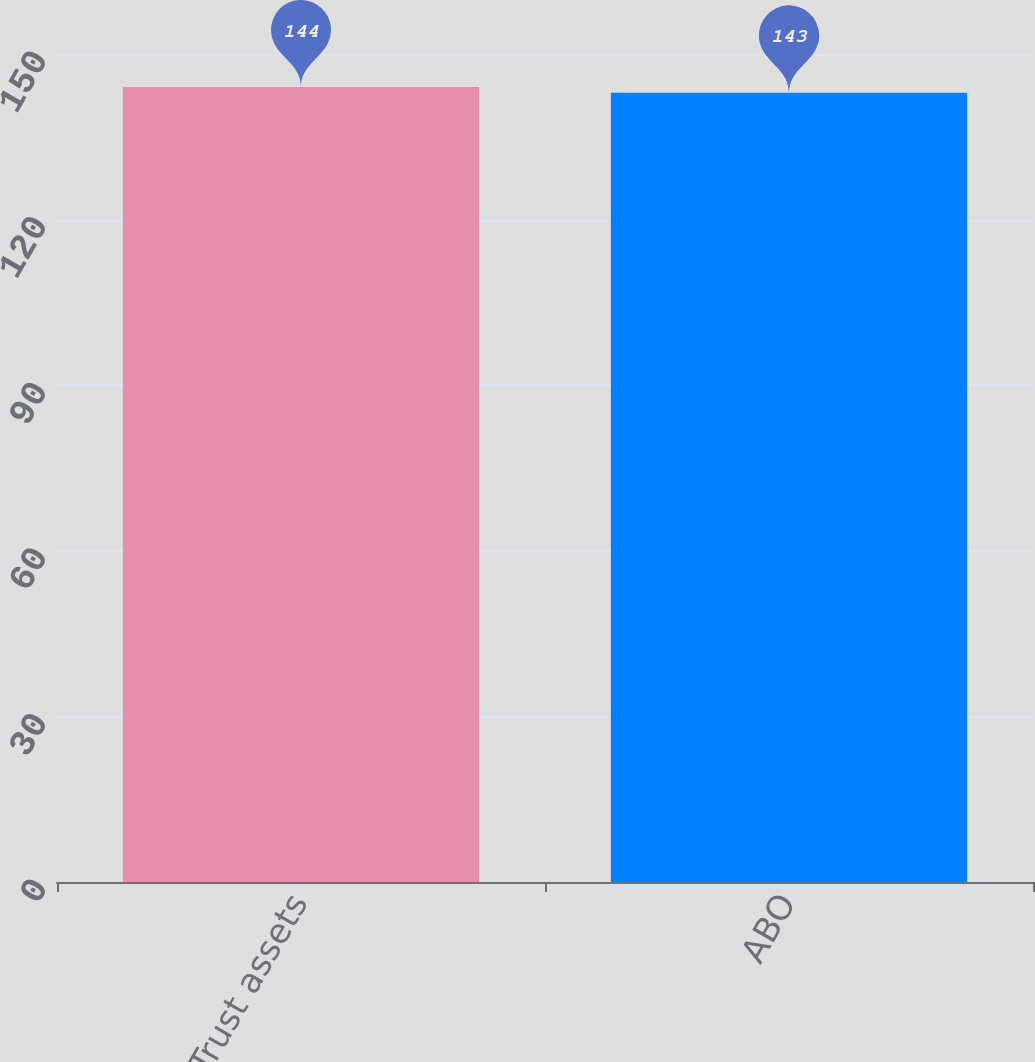Convert chart to OTSL. <chart><loc_0><loc_0><loc_500><loc_500><bar_chart><fcel>Trust assets<fcel>ABO<nl><fcel>144<fcel>143<nl></chart> 